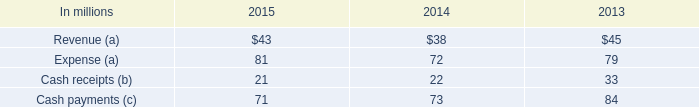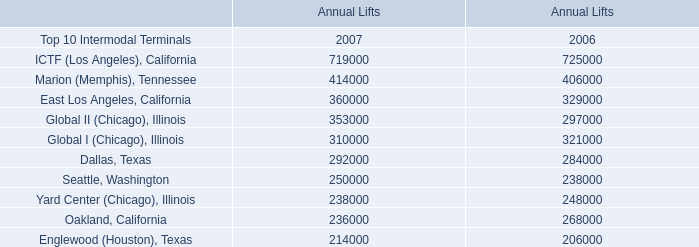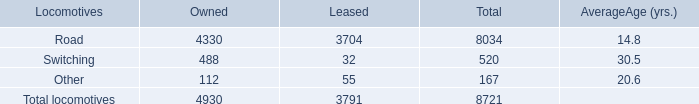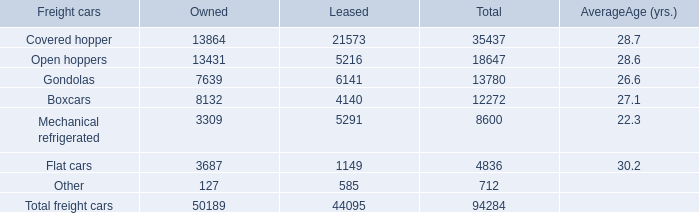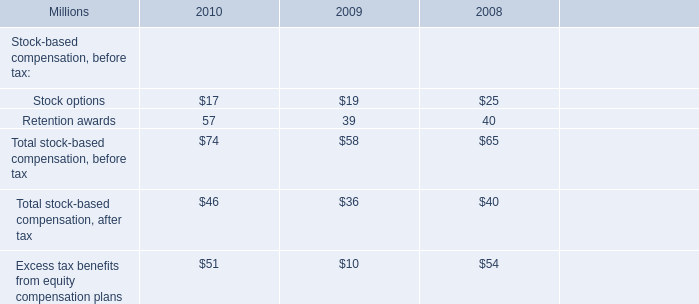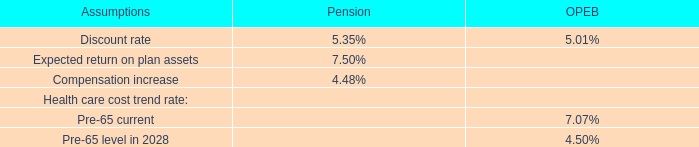As As the chart 1 shows, which year is the Annual Lifts for the Top 10 Intermodal Terminals Dallas, Texas greater than 290000? 
Answer: 2007. 